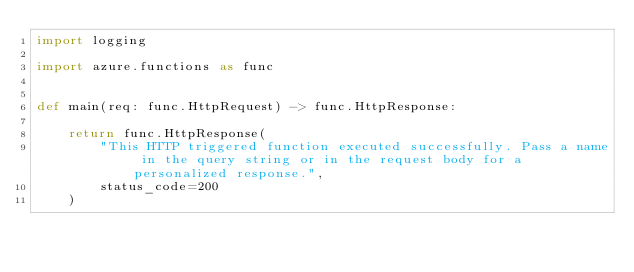<code> <loc_0><loc_0><loc_500><loc_500><_Python_>import logging

import azure.functions as func


def main(req: func.HttpRequest) -> func.HttpResponse:
    
    return func.HttpResponse(
        "This HTTP triggered function executed successfully. Pass a name in the query string or in the request body for a personalized response.",
        status_code=200
    )
</code> 